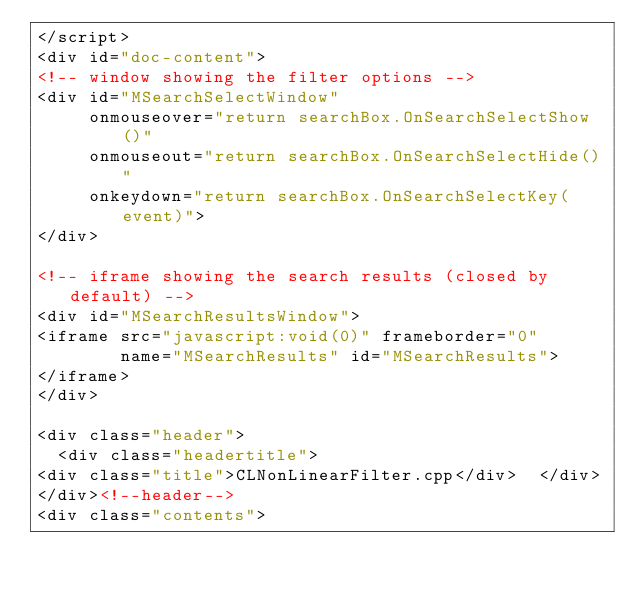Convert code to text. <code><loc_0><loc_0><loc_500><loc_500><_HTML_></script>
<div id="doc-content">
<!-- window showing the filter options -->
<div id="MSearchSelectWindow"
     onmouseover="return searchBox.OnSearchSelectShow()"
     onmouseout="return searchBox.OnSearchSelectHide()"
     onkeydown="return searchBox.OnSearchSelectKey(event)">
</div>

<!-- iframe showing the search results (closed by default) -->
<div id="MSearchResultsWindow">
<iframe src="javascript:void(0)" frameborder="0" 
        name="MSearchResults" id="MSearchResults">
</iframe>
</div>

<div class="header">
  <div class="headertitle">
<div class="title">CLNonLinearFilter.cpp</div>  </div>
</div><!--header-->
<div class="contents"></code> 